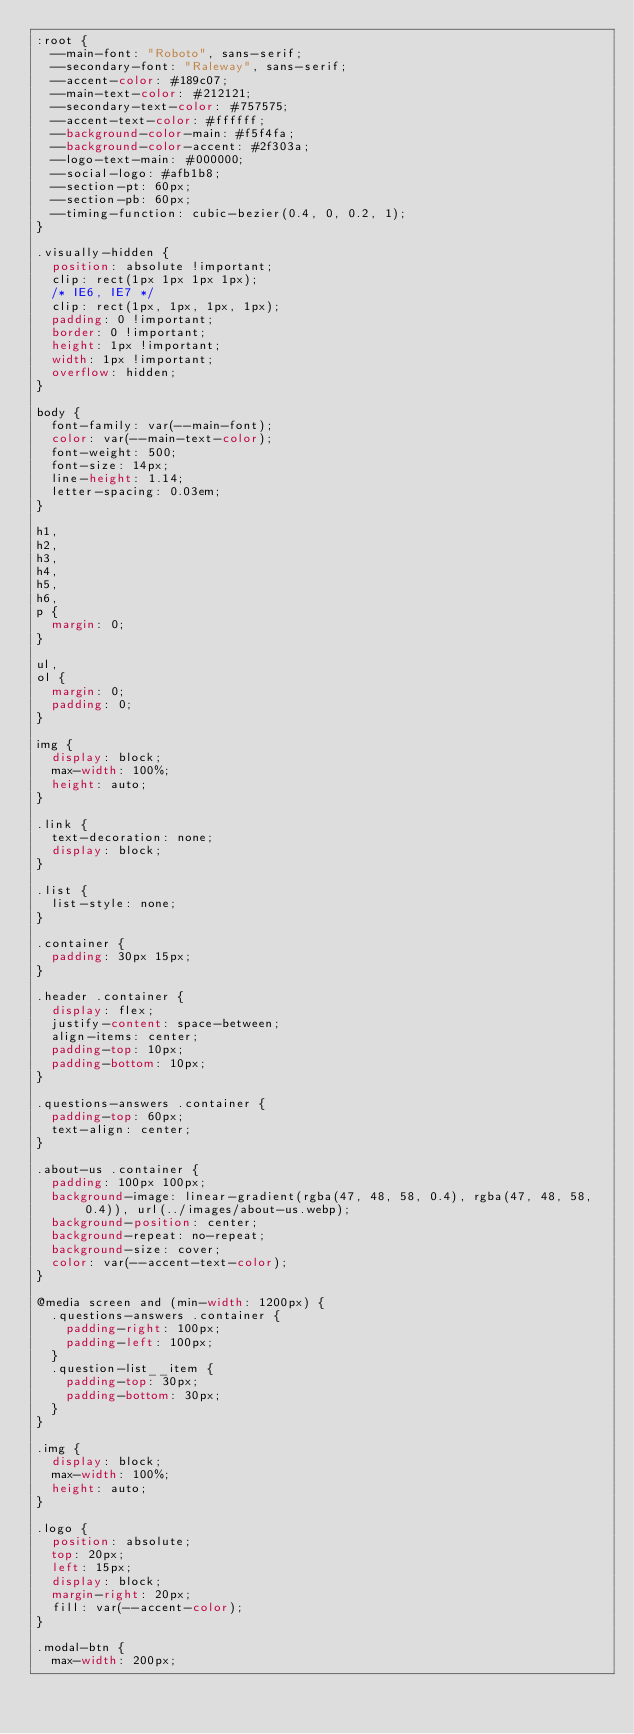<code> <loc_0><loc_0><loc_500><loc_500><_CSS_>:root {
  --main-font: "Roboto", sans-serif;
  --secondary-font: "Raleway", sans-serif;
  --accent-color: #189c07;
  --main-text-color: #212121;
  --secondary-text-color: #757575;
  --accent-text-color: #ffffff;
  --background-color-main: #f5f4fa;
  --background-color-accent: #2f303a;
  --logo-text-main: #000000;
  --social-logo: #afb1b8;
  --section-pt: 60px;
  --section-pb: 60px;
  --timing-function: cubic-bezier(0.4, 0, 0.2, 1);
}

.visually-hidden {
  position: absolute !important;
  clip: rect(1px 1px 1px 1px);
  /* IE6, IE7 */
  clip: rect(1px, 1px, 1px, 1px);
  padding: 0 !important;
  border: 0 !important;
  height: 1px !important;
  width: 1px !important;
  overflow: hidden;
}

body {
  font-family: var(--main-font);
  color: var(--main-text-color);
  font-weight: 500;
  font-size: 14px;
  line-height: 1.14;
  letter-spacing: 0.03em;
}

h1,
h2,
h3,
h4,
h5,
h6,
p {
  margin: 0;
}

ul,
ol {
  margin: 0;
  padding: 0;
}

img {
  display: block;
  max-width: 100%;
  height: auto;
}

.link {
  text-decoration: none;
  display: block;
}

.list {
  list-style: none;
}

.container {
  padding: 30px 15px;
}

.header .container {
  display: flex;
  justify-content: space-between;
  align-items: center;
  padding-top: 10px;
  padding-bottom: 10px;
}

.questions-answers .container {
  padding-top: 60px;
  text-align: center;
}

.about-us .container {
  padding: 100px 100px;
  background-image: linear-gradient(rgba(47, 48, 58, 0.4), rgba(47, 48, 58, 0.4)), url(../images/about-us.webp);
  background-position: center;
  background-repeat: no-repeat;
  background-size: cover;
  color: var(--accent-text-color);
}

@media screen and (min-width: 1200px) {
  .questions-answers .container {
    padding-right: 100px;
    padding-left: 100px;
  }
  .question-list__item {
    padding-top: 30px;
    padding-bottom: 30px;
  }
}

.img {
  display: block;
  max-width: 100%;
  height: auto;
}

.logo {
  position: absolute;
  top: 20px;
  left: 15px;
  display: block;
  margin-right: 20px;
  fill: var(--accent-color);
}

.modal-btn {
  max-width: 200px;</code> 